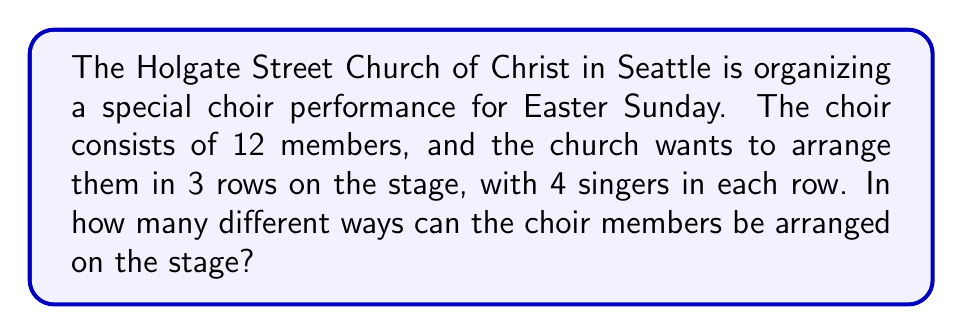Show me your answer to this math problem. Let's approach this step-by-step:

1) First, we need to understand that this is a permutation problem. We are arranging all 12 choir members, and the order matters.

2) We can think of this as filling 12 distinct positions (3 rows of 4 each) with 12 distinct people.

3) For the first position, we have 12 choices.

4) For the second position, we have 11 choices.

5) For the third position, we have 10 choices.

6) This pattern continues until we fill all 12 positions.

7) Therefore, the total number of arrangements is:

   $$ 12 \times 11 \times 10 \times 9 \times 8 \times 7 \times 6 \times 5 \times 4 \times 3 \times 2 \times 1 $$

8) This is also known as 12 factorial, written as $12!$

9) We can calculate this:

   $$ 12! = 479,001,600 $$

Therefore, there are 479,001,600 different ways to arrange the 12 choir members in 3 rows of 4 each on the stage.
Answer: 479,001,600 